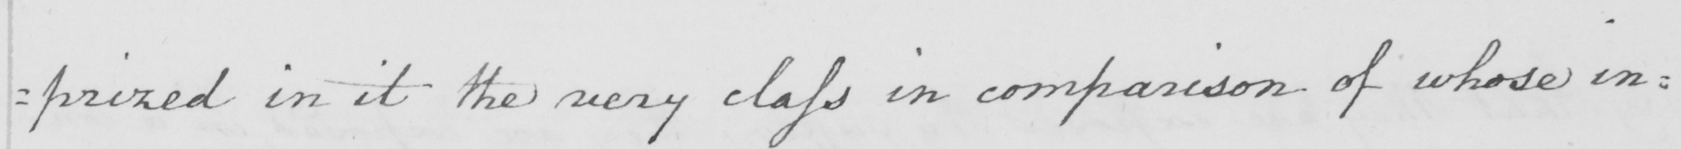What text is written in this handwritten line? =prized in it the very class in comparison of whose in= 